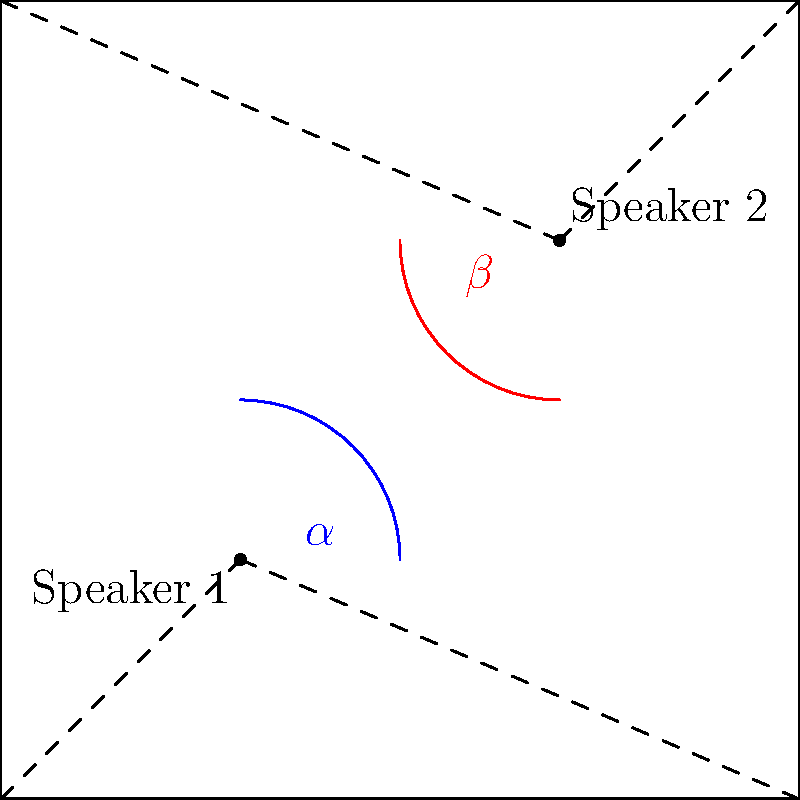In your dining area, you've placed two speakers diagonally across from each other to create an immersive audio experience for your dinner parties. Speaker 1 is positioned in the southwest corner, and Speaker 2 is in the northeast corner. The sound waves from each speaker create angles $\alpha$ and $\beta$ respectively, as shown in the diagram. If $\alpha = 60°$, what is the value of $\beta$? Let's approach this step-by-step:

1) First, observe that the speakers are placed in diagonally opposite corners of what appears to be a square dining area.

2) The sound waves from each speaker form right angles (90°) at the corner where they're placed. This is because sound waves spread out in all directions from their source.

3) In a square, the diagonally opposite corners form supplementary angles. This means that the sum of these angles is always 180°.

4) The angle formed by the sound waves from Speaker 1 ($\alpha$) and the angle formed by the sound waves from Speaker 2 ($\beta$) together make up this 180° angle.

5) We can express this relationship mathematically as:

   $\alpha + \beta = 180°$

6) We're given that $\alpha = 60°$. Let's substitute this into our equation:

   $60° + \beta = 180°$

7) To solve for $\beta$, we subtract 60° from both sides:

   $\beta = 180° - 60° = 120°$

Therefore, the value of $\beta$ is 120°.
Answer: 120° 